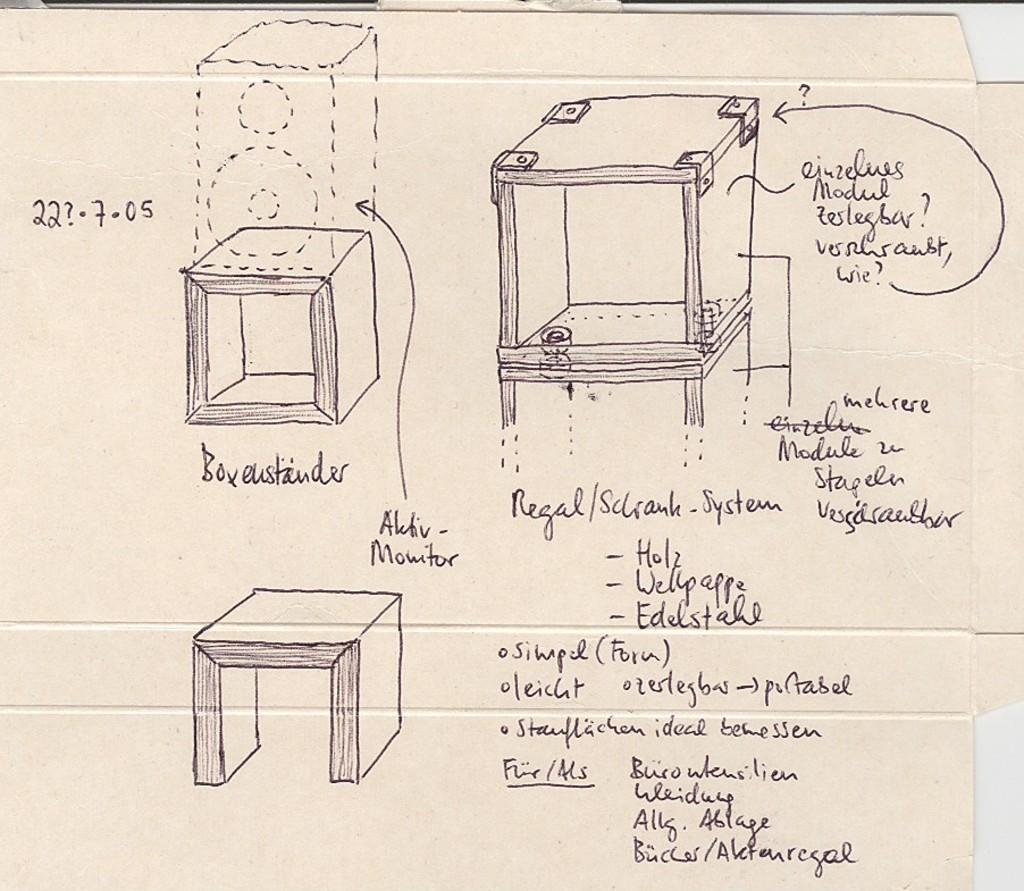How would you summarize this image in a sentence or two? In the image we can see there is a poster on which there are drawings are done and there is a matter written on it. 